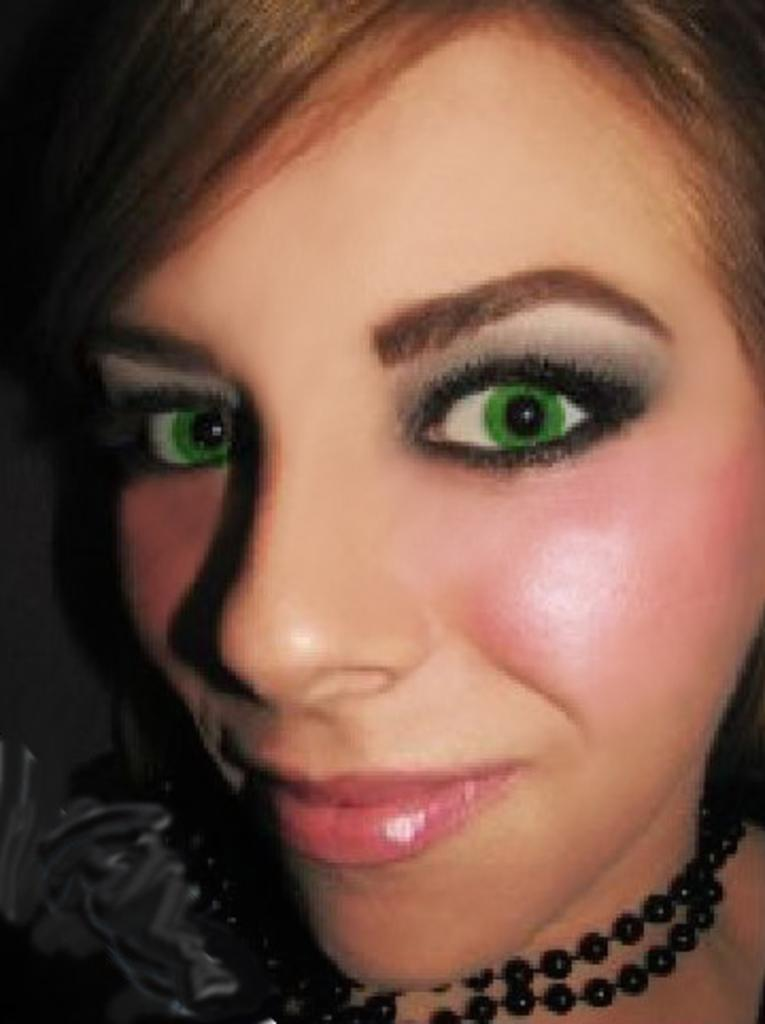What is the main subject of the image? The main subject of the image is a woman's face. Can you describe any accessories the woman is wearing? The woman is wearing a chain in the image. What type of request is the woman making in the image? There is no indication in the image that the woman is making any request. Can you tell me the story behind the woman's chain in the image? There is no story provided in the image; it only shows the woman's face and the chain she is wearing. 